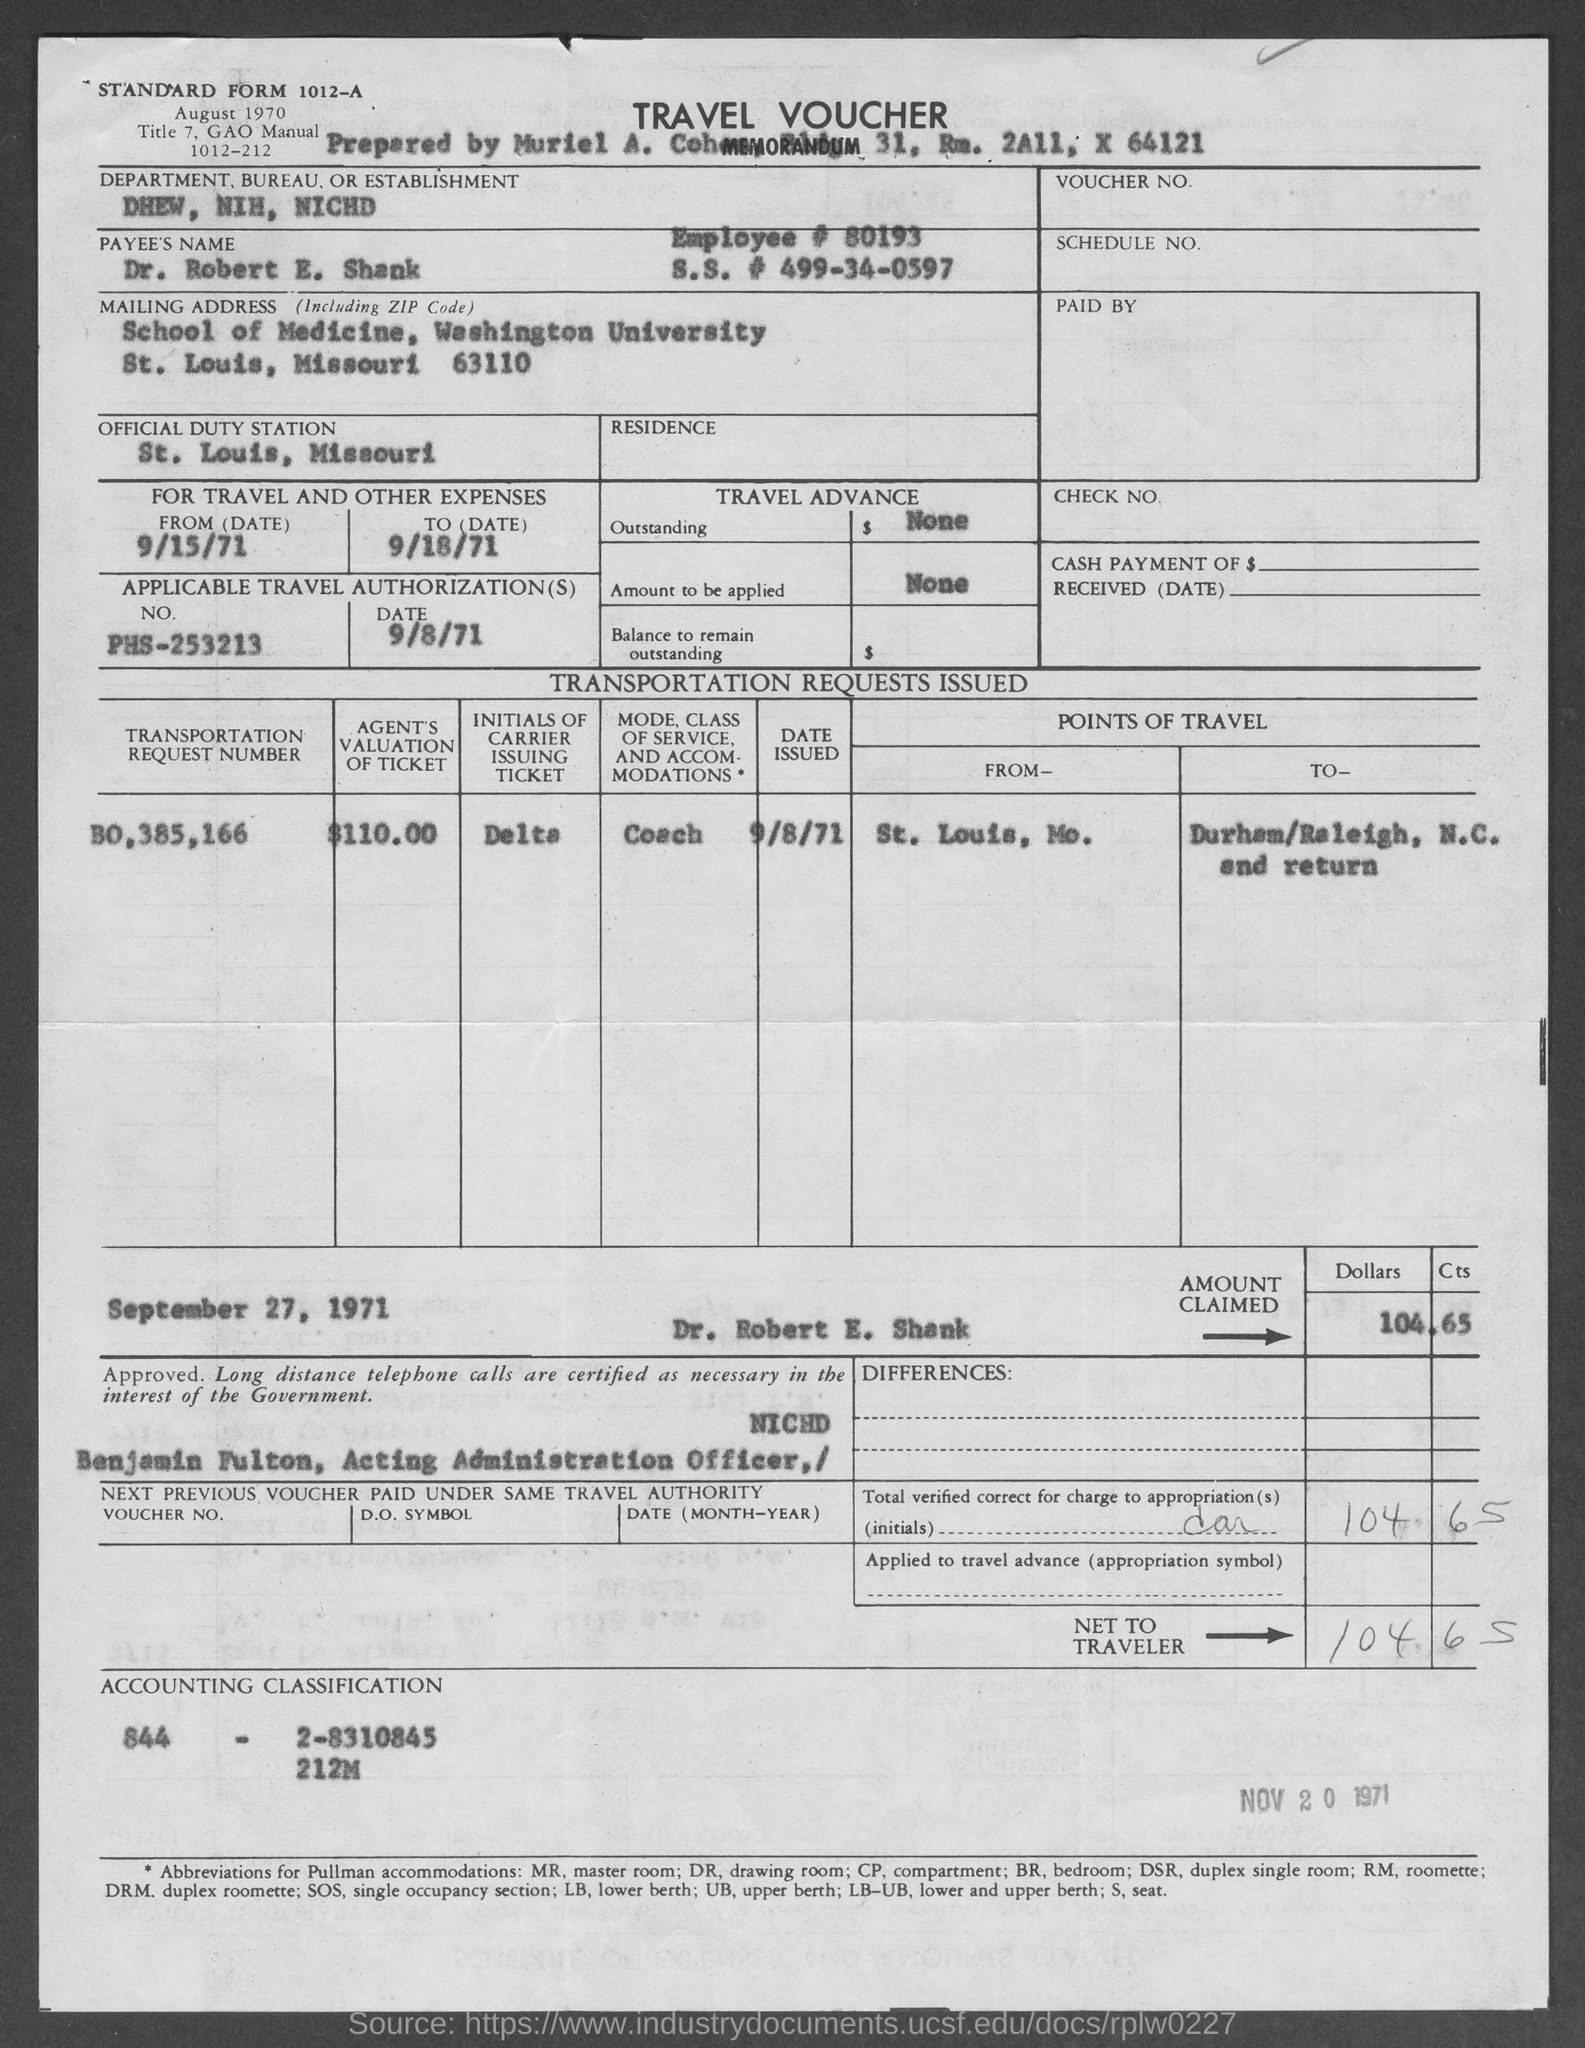What is the Standard Form No. given in the voucher?
Your answer should be very brief. 1012-A. What type of voucher is given here?
Offer a terse response. TRAVEL VOUCHER. What is the Employee # given in the voucher?
Offer a very short reply. 80193. What is the Department, Bureau, or Establishment given in the voucher?
Provide a succinct answer. DHEW, NIH, NICHD. What is the payee's name given in the voucher?
Offer a very short reply. Dr. Robert E. Shank. Which is the official duty station of Dr. Robert E. Shank?
Your answer should be very brief. St. Louis, Missouri. What is the applicable travel authorization no. given in the travel voucher?
Offer a very short reply. PHS-253213. What is the applicable travel authorization date given in the travel voucher?
Offer a terse response. 9/8/71. 